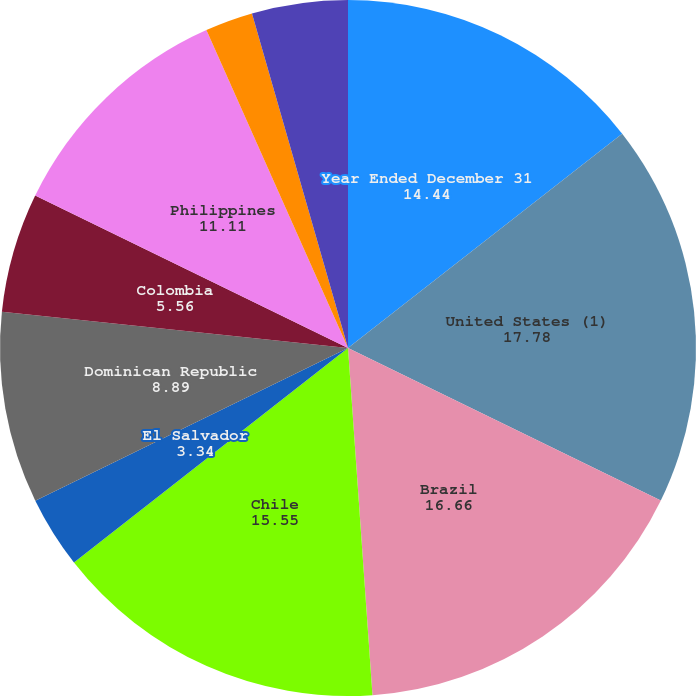<chart> <loc_0><loc_0><loc_500><loc_500><pie_chart><fcel>Year Ended December 31<fcel>United States (1)<fcel>Brazil<fcel>Chile<fcel>El Salvador<fcel>Dominican Republic<fcel>Colombia<fcel>Philippines<fcel>Argentina<fcel>United Kingdom<nl><fcel>14.44%<fcel>17.78%<fcel>16.66%<fcel>15.55%<fcel>3.34%<fcel>8.89%<fcel>5.56%<fcel>11.11%<fcel>2.22%<fcel>4.45%<nl></chart> 